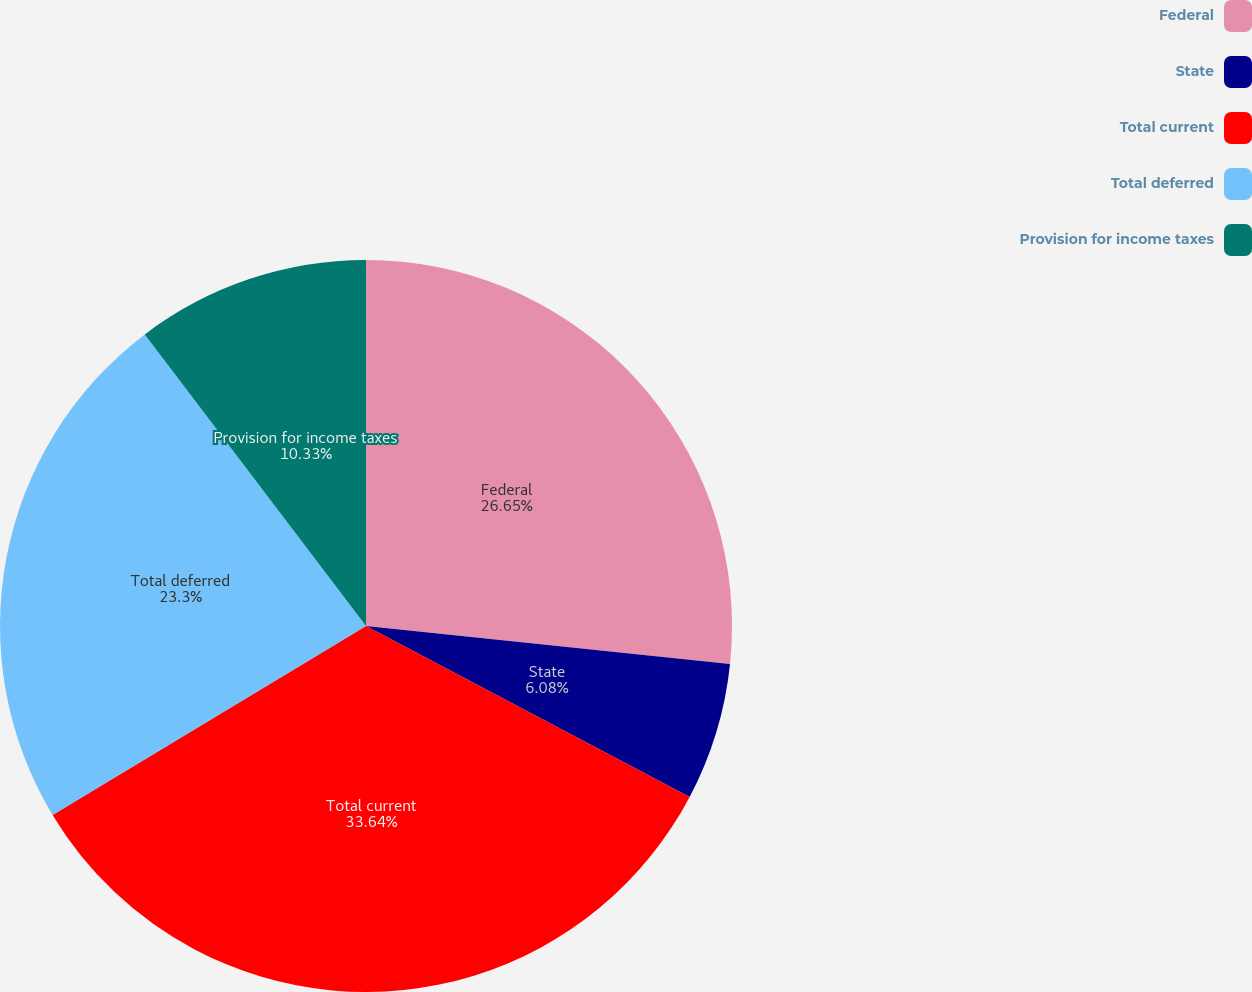<chart> <loc_0><loc_0><loc_500><loc_500><pie_chart><fcel>Federal<fcel>State<fcel>Total current<fcel>Total deferred<fcel>Provision for income taxes<nl><fcel>26.65%<fcel>6.08%<fcel>33.63%<fcel>23.3%<fcel>10.33%<nl></chart> 